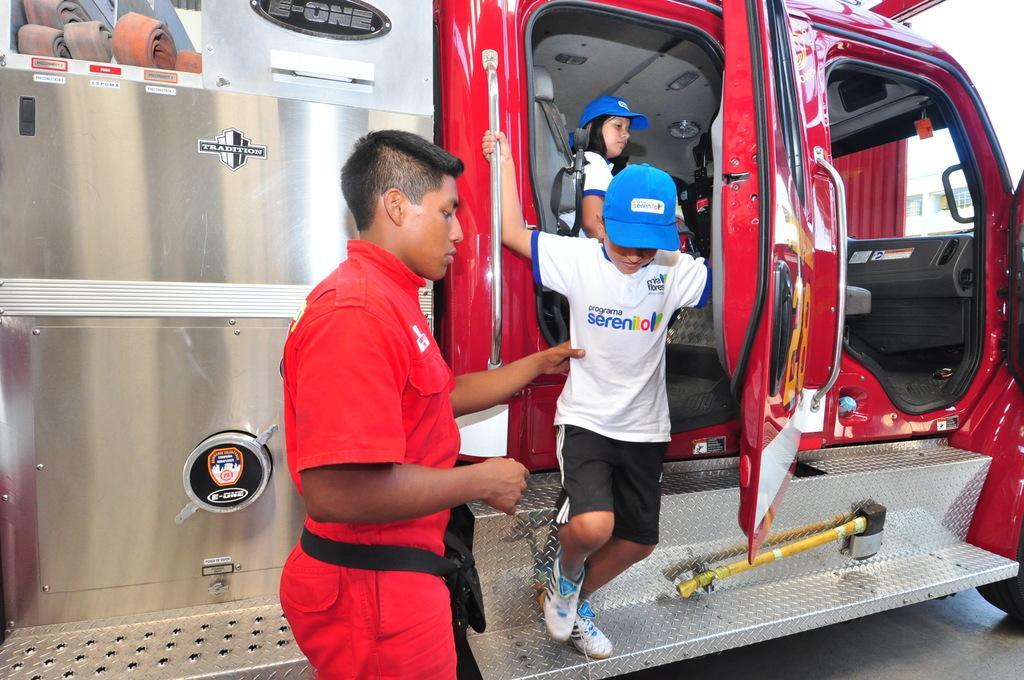Describe this image in one or two sentences. In this image, there is a red color car, there is a kid coming out from the car, in the left side there is a man standing and holding a kid, there is a woman sitting in the car. 